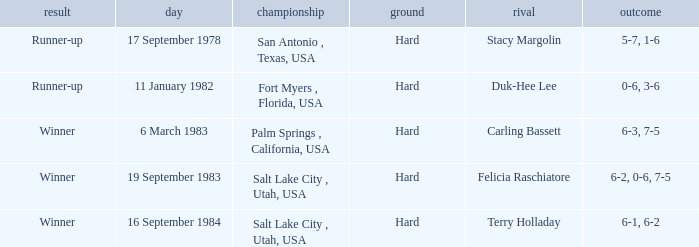What was the outcome of the match against Stacy Margolin? Runner-up. 